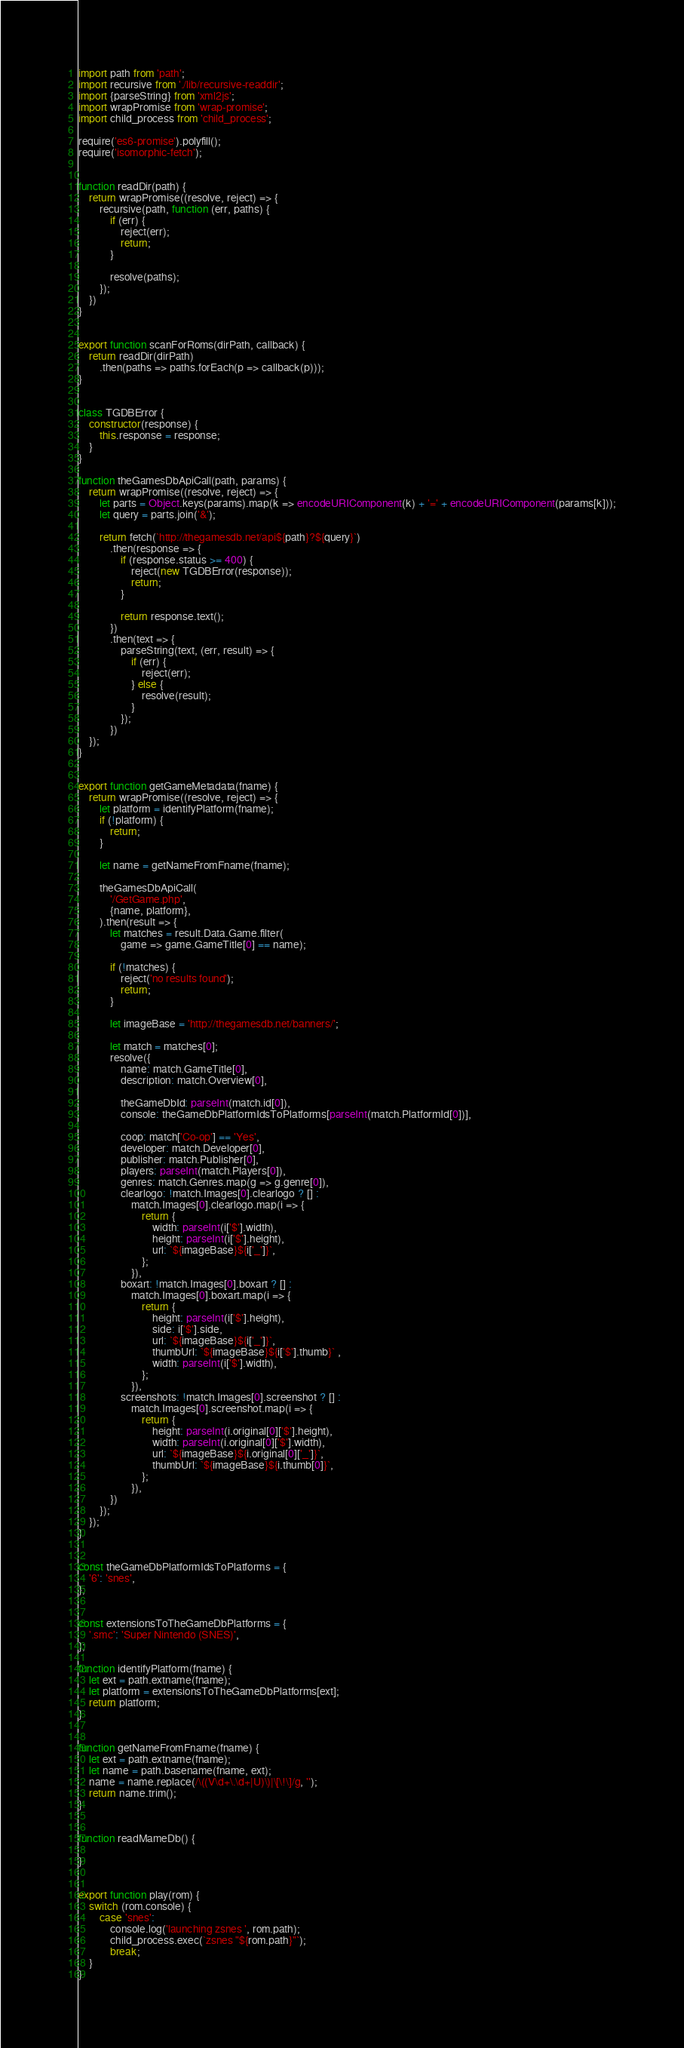Convert code to text. <code><loc_0><loc_0><loc_500><loc_500><_JavaScript_>import path from 'path';
import recursive from './lib/recursive-readdir';
import {parseString} from 'xml2js';
import wrapPromise from 'wrap-promise';
import child_process from 'child_process';

require('es6-promise').polyfill();
require('isomorphic-fetch');


function readDir(path) {
    return wrapPromise((resolve, reject) => {
        recursive(path, function (err, paths) {
            if (err) {
                reject(err);
                return;
            }

            resolve(paths);
        });
    })
}


export function scanForRoms(dirPath, callback) {
    return readDir(dirPath)
        .then(paths => paths.forEach(p => callback(p)));
}


class TGDBError {
    constructor(response) {
        this.response = response;
    }
}

function theGamesDbApiCall(path, params) {
    return wrapPromise((resolve, reject) => {
        let parts = Object.keys(params).map(k => encodeURIComponent(k) + '=' + encodeURIComponent(params[k]));
        let query = parts.join('&');

        return fetch(`http://thegamesdb.net/api${path}?${query}`)
            .then(response => {
                if (response.status >= 400) {
                    reject(new TGDBError(response));
                    return;
                }

                return response.text();
            })
            .then(text => {
                parseString(text, (err, result) => {
                    if (err) {
                        reject(err);
                    } else {
                        resolve(result);
                    }
                });
            })
    });
}


export function getGameMetadata(fname) {
    return wrapPromise((resolve, reject) => {
        let platform = identifyPlatform(fname);
        if (!platform) {
            return;
        }

        let name = getNameFromFname(fname);

        theGamesDbApiCall(
            '/GetGame.php',
            {name, platform},
        ).then(result => {
            let matches = result.Data.Game.filter(
                game => game.GameTitle[0] == name);

            if (!matches) {
                reject('no results found');
                return;
            }

            let imageBase = 'http://thegamesdb.net/banners/';

            let match = matches[0];
            resolve({
                name: match.GameTitle[0],
                description: match.Overview[0],

                theGameDbId: parseInt(match.id[0]),
                console: theGameDbPlatformIdsToPlatforms[parseInt(match.PlatformId[0])],

                coop: match['Co-op'] == 'Yes',
                developer: match.Developer[0],
                publisher: match.Publisher[0],
                players: parseInt(match.Players[0]),
                genres: match.Genres.map(g => g.genre[0]),
                clearlogo: !match.Images[0].clearlogo ? [] :
                    match.Images[0].clearlogo.map(i => {
                        return {
                            width: parseInt(i['$'].width),
                            height: parseInt(i['$'].height),
                            url: `${imageBase}${i['_']}`,
                        };
                    }),
                boxart: !match.Images[0].boxart ? [] :
                    match.Images[0].boxart.map(i => {
                        return {
                            height: parseInt(i['$'].height),
                            side: i['$'].side,
                            url: `${imageBase}${i['_']}`,
                            thumbUrl: `${imageBase}${i['$'].thumb}` ,
                            width: parseInt(i['$'].width),
                        };
                    }),
                screenshots: !match.Images[0].screenshot ? [] :
                    match.Images[0].screenshot.map(i => {
                        return {
                            height: parseInt(i.original[0]['$'].height),
                            width: parseInt(i.original[0]['$'].width),
                            url: `${imageBase}${i.original[0]['_']}`,
                            thumbUrl: `${imageBase}${i.thumb[0]}`,
                        };
                    }),
            })
        });
    });
}


const theGameDbPlatformIdsToPlatforms = {
    '6': 'snes',
};


const extensionsToTheGameDbPlatforms = {
    '.smc': 'Super Nintendo (SNES)',
};

function identifyPlatform(fname) {
    let ext = path.extname(fname);
    let platform = extensionsToTheGameDbPlatforms[ext];
    return platform;
}


function getNameFromFname(fname) {
    let ext = path.extname(fname);
    let name = path.basename(fname, ext);
    name = name.replace(/\((V\d+\.\d+|U)\)|\[\!\]/g, '');
    return name.trim();
}


function readMameDb() {

}


export function play(rom) {
    switch (rom.console) {
        case 'snes':
            console.log('launching zsnes ', rom.path);
            child_process.exec(`zsnes "${rom.path}"`);
            break;
    }
}
</code> 